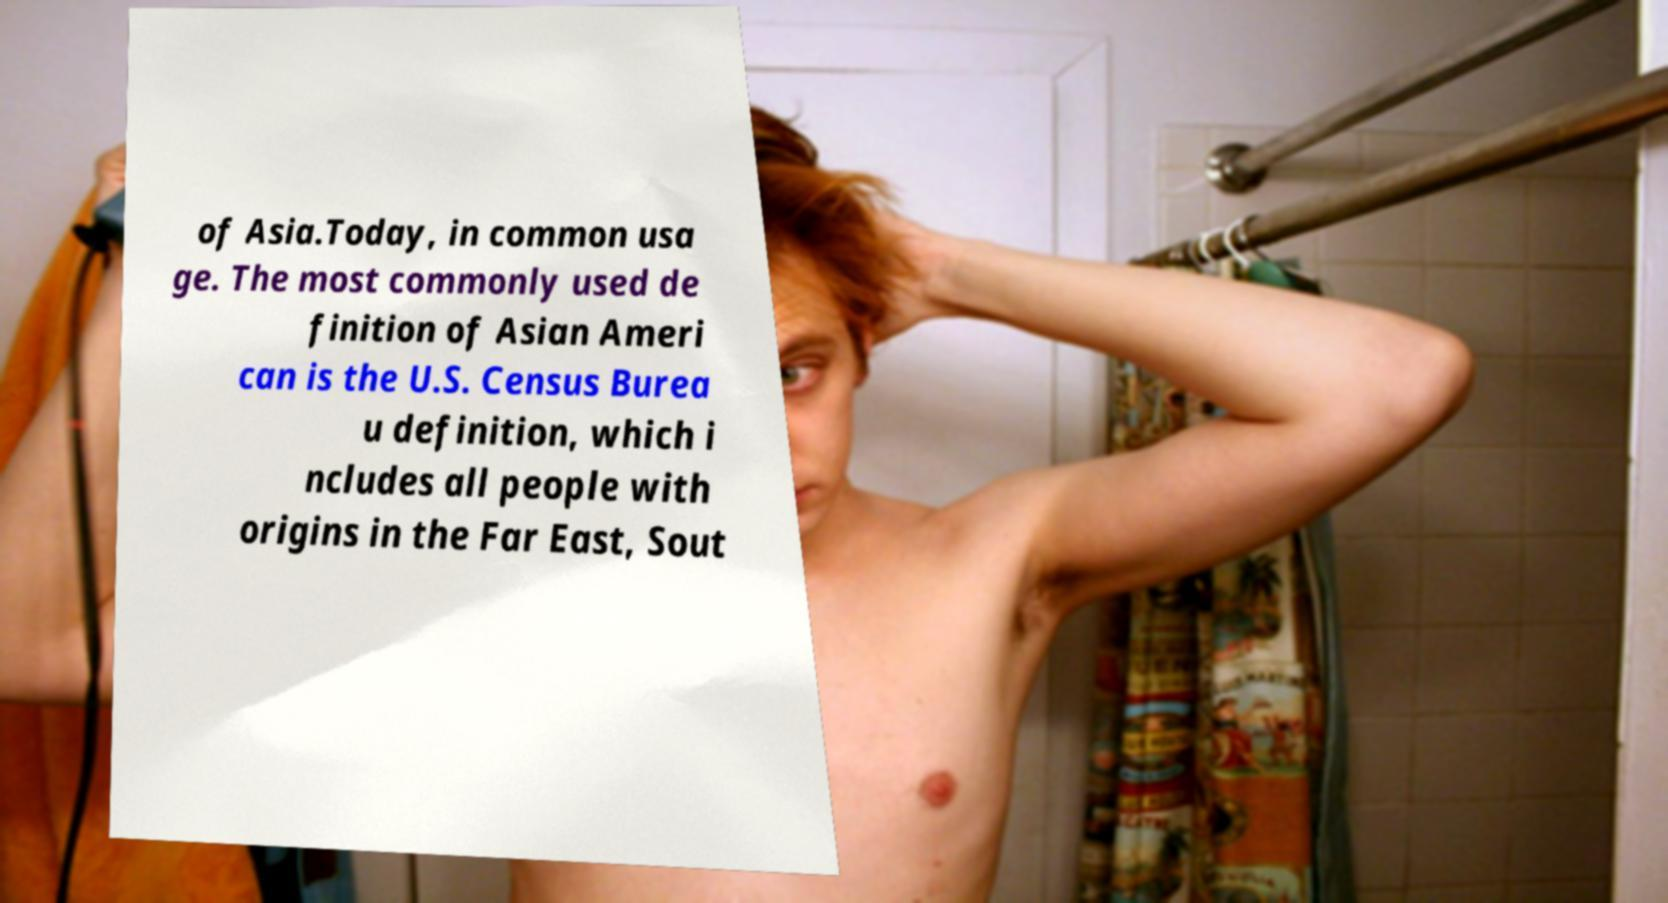Can you read and provide the text displayed in the image?This photo seems to have some interesting text. Can you extract and type it out for me? of Asia.Today, in common usa ge. The most commonly used de finition of Asian Ameri can is the U.S. Census Burea u definition, which i ncludes all people with origins in the Far East, Sout 